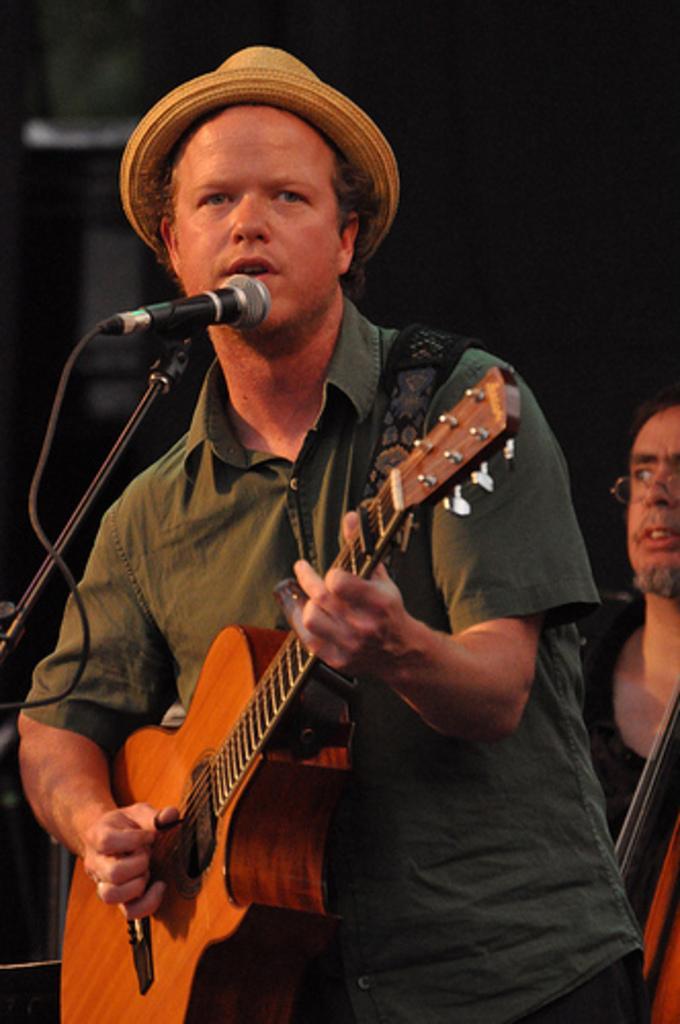Describe this image in one or two sentences. He is a person standing in the center. He is holding a guitar in his hand and he is singing on a microphone. In the background there is another person who is on the right side. 